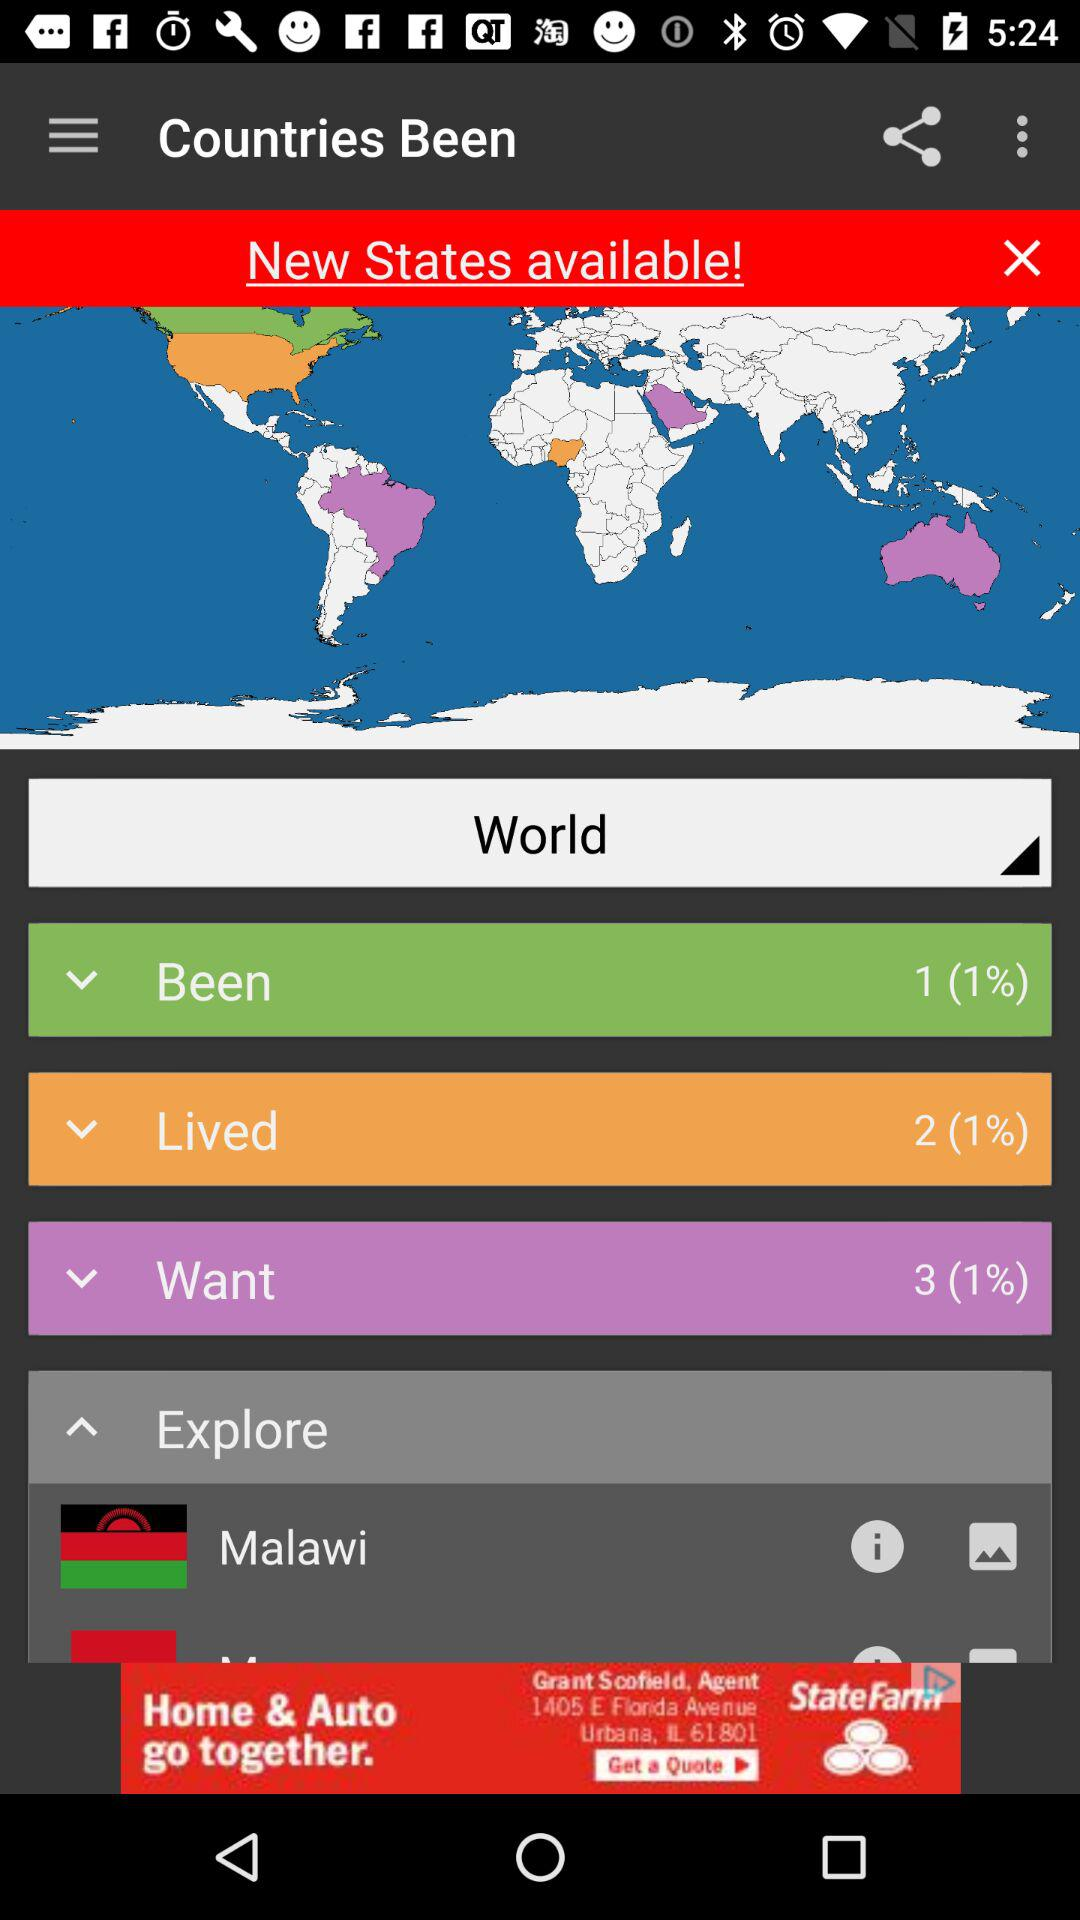What are the countries available in the Explore section? The available country is Malawi. 